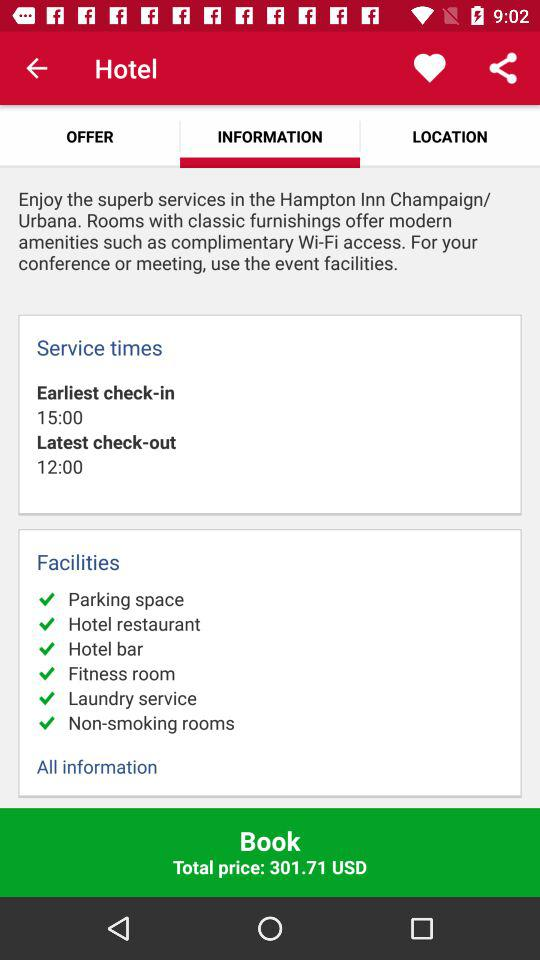What is the total price of the stay?
Answer the question using a single word or phrase. 301.71 USD 